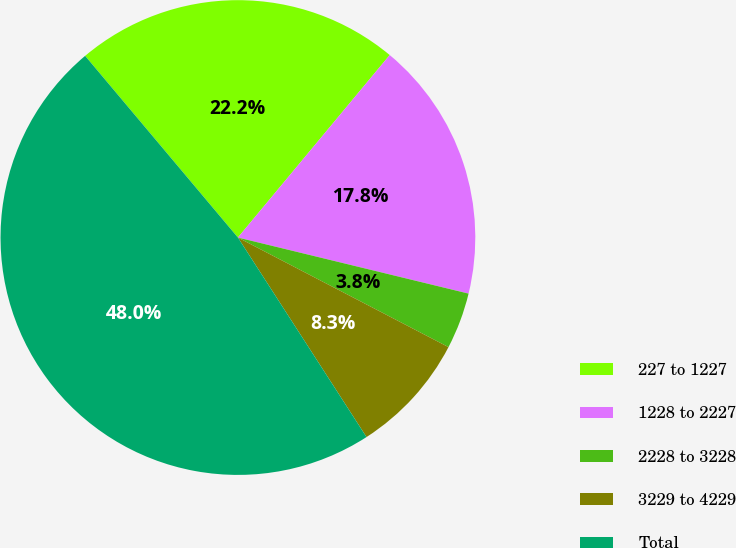Convert chart. <chart><loc_0><loc_0><loc_500><loc_500><pie_chart><fcel>227 to 1227<fcel>1228 to 2227<fcel>2228 to 3228<fcel>3229 to 4229<fcel>Total<nl><fcel>22.17%<fcel>17.75%<fcel>3.84%<fcel>8.25%<fcel>47.98%<nl></chart> 